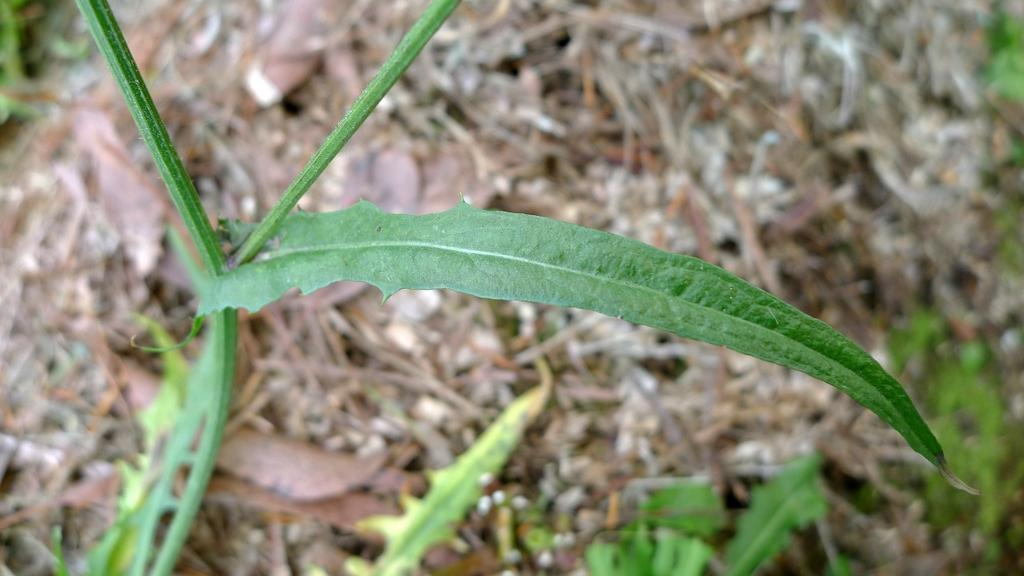What type of living organisms can be seen in the image? Plants can be seen in the image. Can you describe the background of the image? The background of the image is blurry. What type of song is being sung by the parent in the image? There is no reference to a song or a parent in the image, so it is not possible to answer that question. 